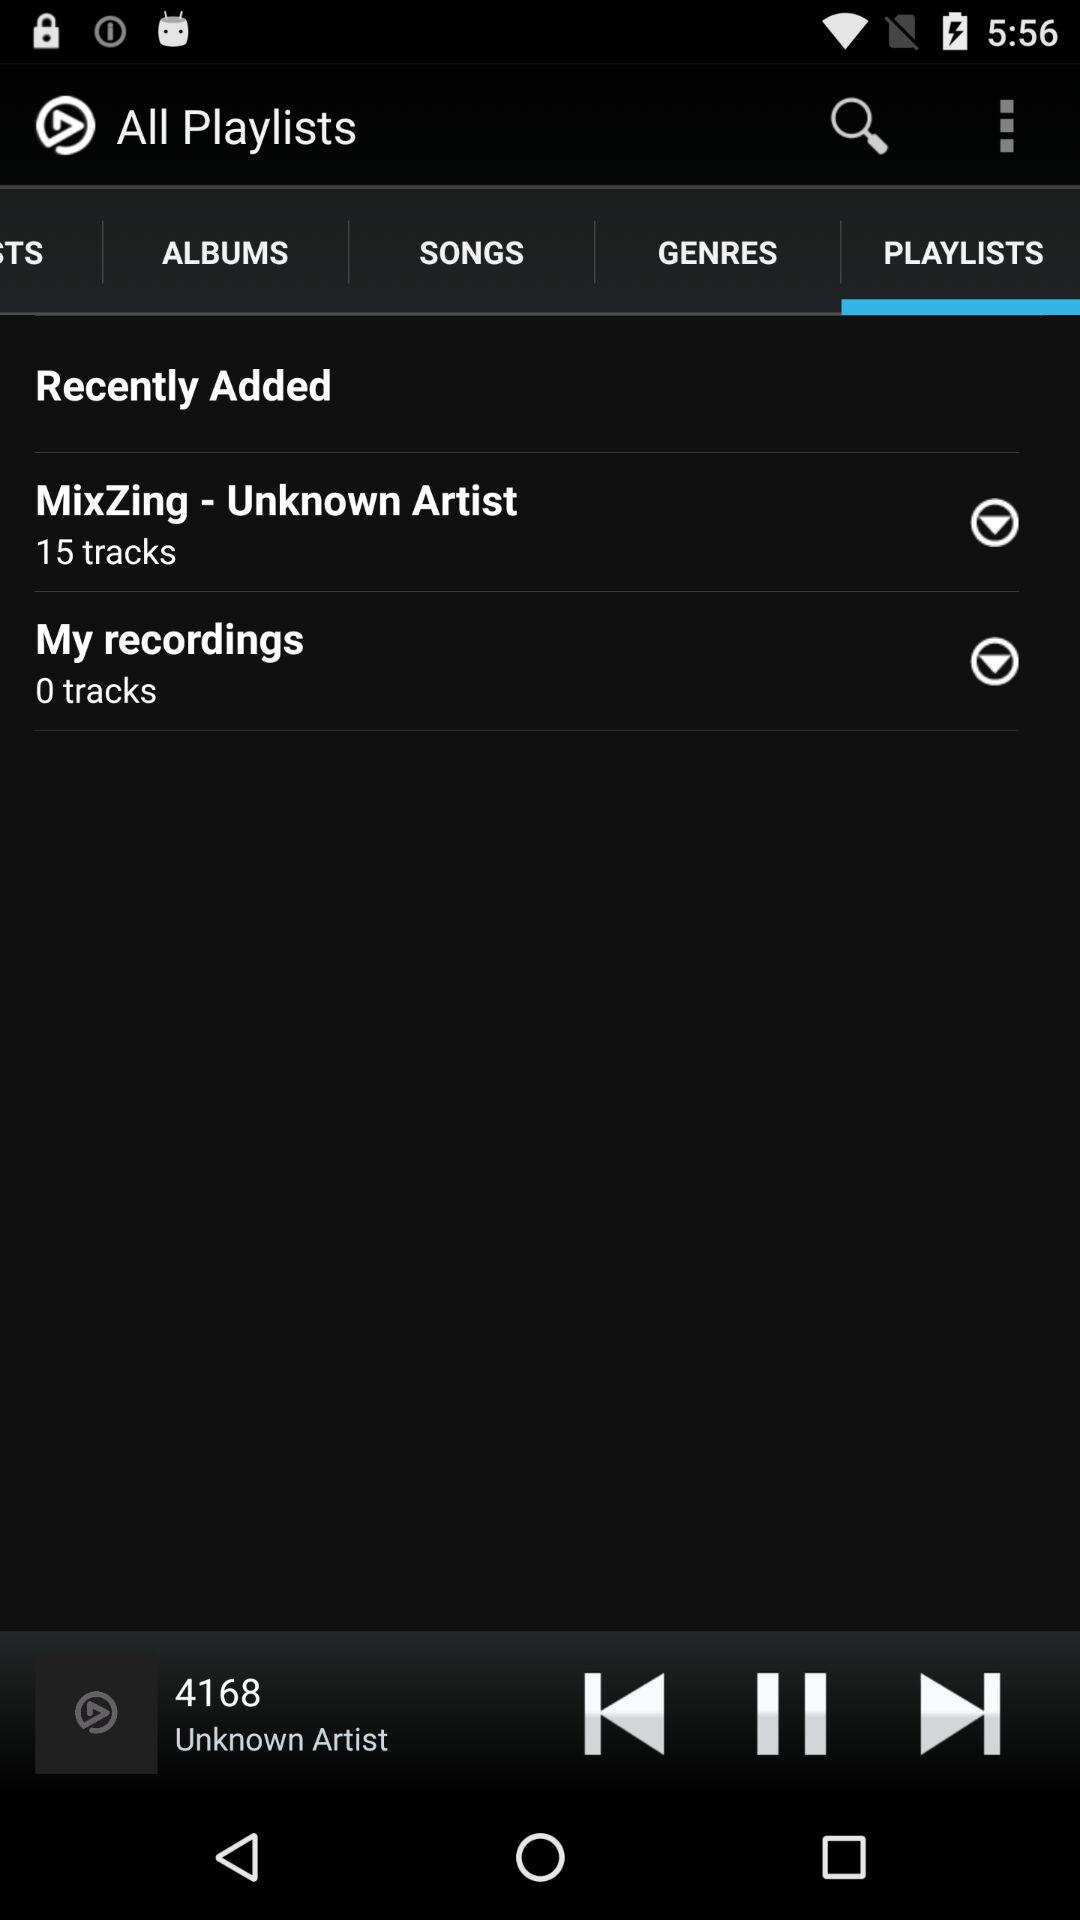What song is currently playing? The currently playing song is 4168. 